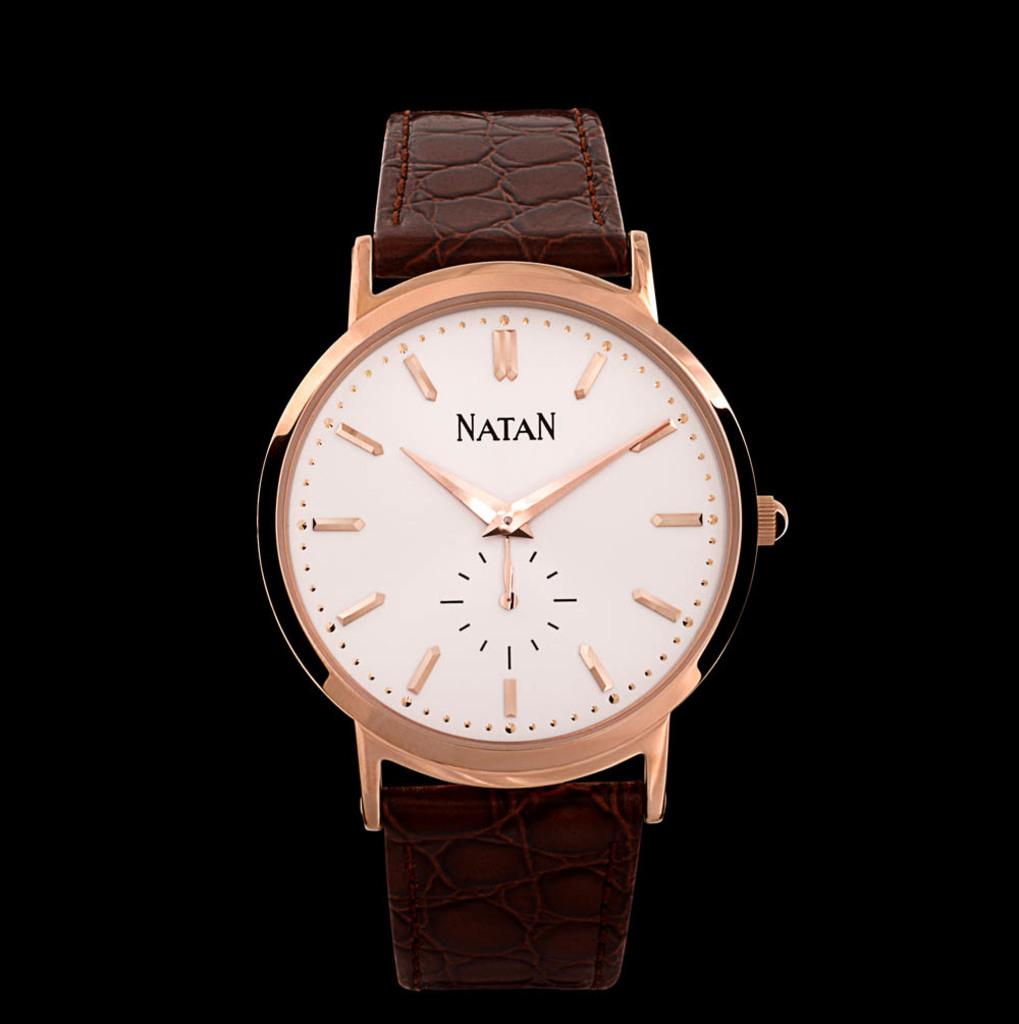What is the brand of the watch?
Offer a very short reply. Natan. What time is shown here?
Provide a short and direct response. 10:10. 